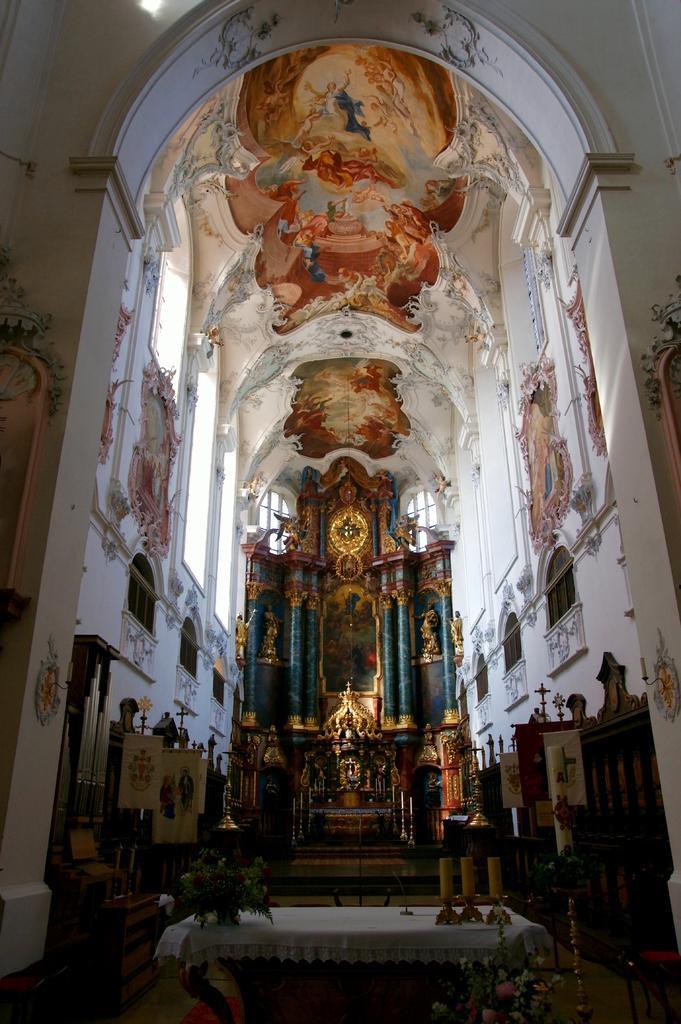In one or two sentences, can you explain what this image depicts? In this image we can see an inside view of a building. In the foreground we can see some candles, plant placed on a table and a group of flowers. In the center of the image we can see statues, photo frame on the wall, pillars. In the background, we can see a group of banners with text and some windows. 